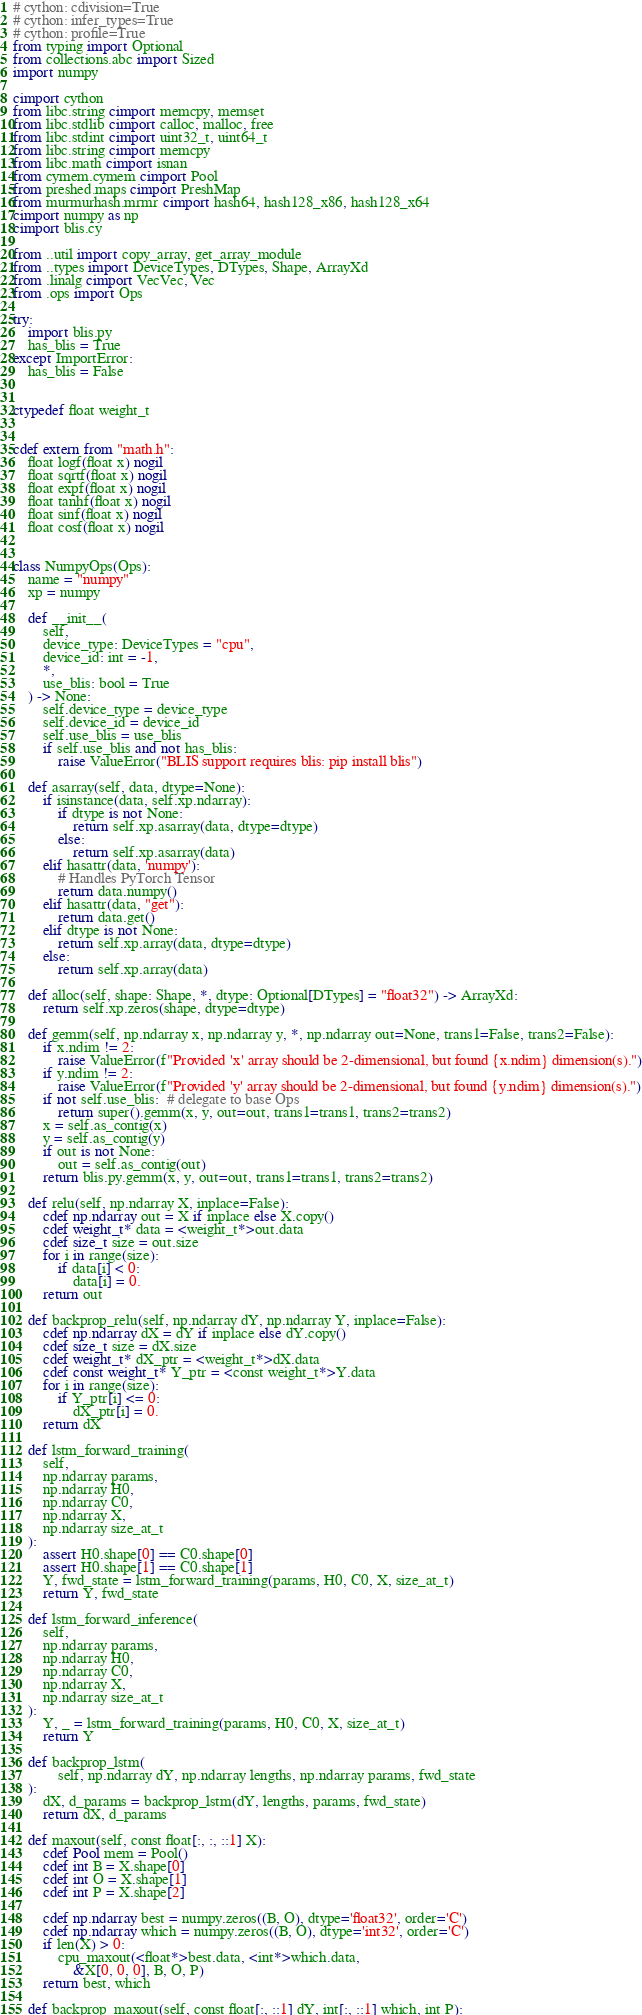<code> <loc_0><loc_0><loc_500><loc_500><_Cython_># cython: cdivision=True
# cython: infer_types=True
# cython: profile=True
from typing import Optional
from collections.abc import Sized
import numpy

cimport cython
from libc.string cimport memcpy, memset
from libc.stdlib cimport calloc, malloc, free
from libc.stdint cimport uint32_t, uint64_t
from libc.string cimport memcpy
from libc.math cimport isnan
from cymem.cymem cimport Pool
from preshed.maps cimport PreshMap
from murmurhash.mrmr cimport hash64, hash128_x86, hash128_x64
cimport numpy as np
cimport blis.cy

from ..util import copy_array, get_array_module
from ..types import DeviceTypes, DTypes, Shape, ArrayXd
from .linalg cimport VecVec, Vec
from .ops import Ops

try:
    import blis.py
    has_blis = True
except ImportError:
    has_blis = False


ctypedef float weight_t


cdef extern from "math.h":
    float logf(float x) nogil
    float sqrtf(float x) nogil
    float expf(float x) nogil
    float tanhf(float x) nogil
    float sinf(float x) nogil
    float cosf(float x) nogil


class NumpyOps(Ops):
    name = "numpy"
    xp = numpy

    def __init__(
        self,
        device_type: DeviceTypes = "cpu",
        device_id: int = -1,
        *,
        use_blis: bool = True
    ) -> None:
        self.device_type = device_type
        self.device_id = device_id
        self.use_blis = use_blis
        if self.use_blis and not has_blis:
            raise ValueError("BLIS support requires blis: pip install blis")

    def asarray(self, data, dtype=None):
        if isinstance(data, self.xp.ndarray):
            if dtype is not None:
                return self.xp.asarray(data, dtype=dtype)
            else:
                return self.xp.asarray(data)
        elif hasattr(data, 'numpy'):
            # Handles PyTorch Tensor
            return data.numpy()
        elif hasattr(data, "get"):
            return data.get()
        elif dtype is not None:
            return self.xp.array(data, dtype=dtype)
        else:
            return self.xp.array(data)

    def alloc(self, shape: Shape, *, dtype: Optional[DTypes] = "float32") -> ArrayXd:
        return self.xp.zeros(shape, dtype=dtype)

    def gemm(self, np.ndarray x, np.ndarray y, *, np.ndarray out=None, trans1=False, trans2=False):
        if x.ndim != 2:
            raise ValueError(f"Provided 'x' array should be 2-dimensional, but found {x.ndim} dimension(s).")
        if y.ndim != 2:
            raise ValueError(f"Provided 'y' array should be 2-dimensional, but found {y.ndim} dimension(s).")
        if not self.use_blis:  # delegate to base Ops
            return super().gemm(x, y, out=out, trans1=trans1, trans2=trans2)
        x = self.as_contig(x)
        y = self.as_contig(y)
        if out is not None:
            out = self.as_contig(out)
        return blis.py.gemm(x, y, out=out, trans1=trans1, trans2=trans2)

    def relu(self, np.ndarray X, inplace=False):
        cdef np.ndarray out = X if inplace else X.copy()
        cdef weight_t* data = <weight_t*>out.data
        cdef size_t size = out.size
        for i in range(size):
            if data[i] < 0:
                data[i] = 0.
        return out

    def backprop_relu(self, np.ndarray dY, np.ndarray Y, inplace=False):
        cdef np.ndarray dX = dY if inplace else dY.copy()
        cdef size_t size = dX.size
        cdef weight_t* dX_ptr = <weight_t*>dX.data
        cdef const weight_t* Y_ptr = <const weight_t*>Y.data
        for i in range(size):
            if Y_ptr[i] <= 0:
                dX_ptr[i] = 0.
        return dX

    def lstm_forward_training(
        self,
        np.ndarray params,
        np.ndarray H0,
        np.ndarray C0,
        np.ndarray X,
        np.ndarray size_at_t
    ):
        assert H0.shape[0] == C0.shape[0]
        assert H0.shape[1] == C0.shape[1]
        Y, fwd_state = lstm_forward_training(params, H0, C0, X, size_at_t)
        return Y, fwd_state

    def lstm_forward_inference(
        self,
        np.ndarray params,
        np.ndarray H0,
        np.ndarray C0,
        np.ndarray X,
        np.ndarray size_at_t
    ):
        Y, _ = lstm_forward_training(params, H0, C0, X, size_at_t)
        return Y

    def backprop_lstm(
            self, np.ndarray dY, np.ndarray lengths, np.ndarray params, fwd_state
    ):
        dX, d_params = backprop_lstm(dY, lengths, params, fwd_state)
        return dX, d_params

    def maxout(self, const float[:, :, ::1] X):
        cdef Pool mem = Pool()
        cdef int B = X.shape[0]
        cdef int O = X.shape[1]
        cdef int P = X.shape[2]

        cdef np.ndarray best = numpy.zeros((B, O), dtype='float32', order='C')
        cdef np.ndarray which = numpy.zeros((B, O), dtype='int32', order='C')
        if len(X) > 0:
            cpu_maxout(<float*>best.data, <int*>which.data,
                &X[0, 0, 0], B, O, P)
        return best, which

    def backprop_maxout(self, const float[:, ::1] dY, int[:, ::1] which, int P):</code> 